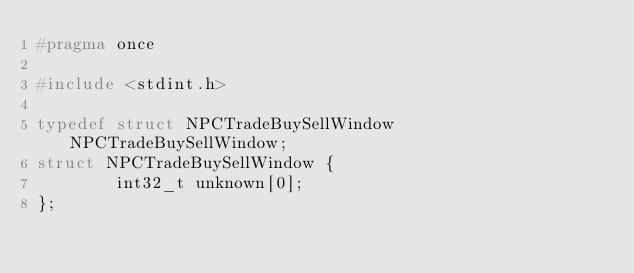<code> <loc_0><loc_0><loc_500><loc_500><_C_>#pragma once

#include <stdint.h>

typedef struct NPCTradeBuySellWindow NPCTradeBuySellWindow;
struct NPCTradeBuySellWindow {
        int32_t unknown[0];
};
</code> 